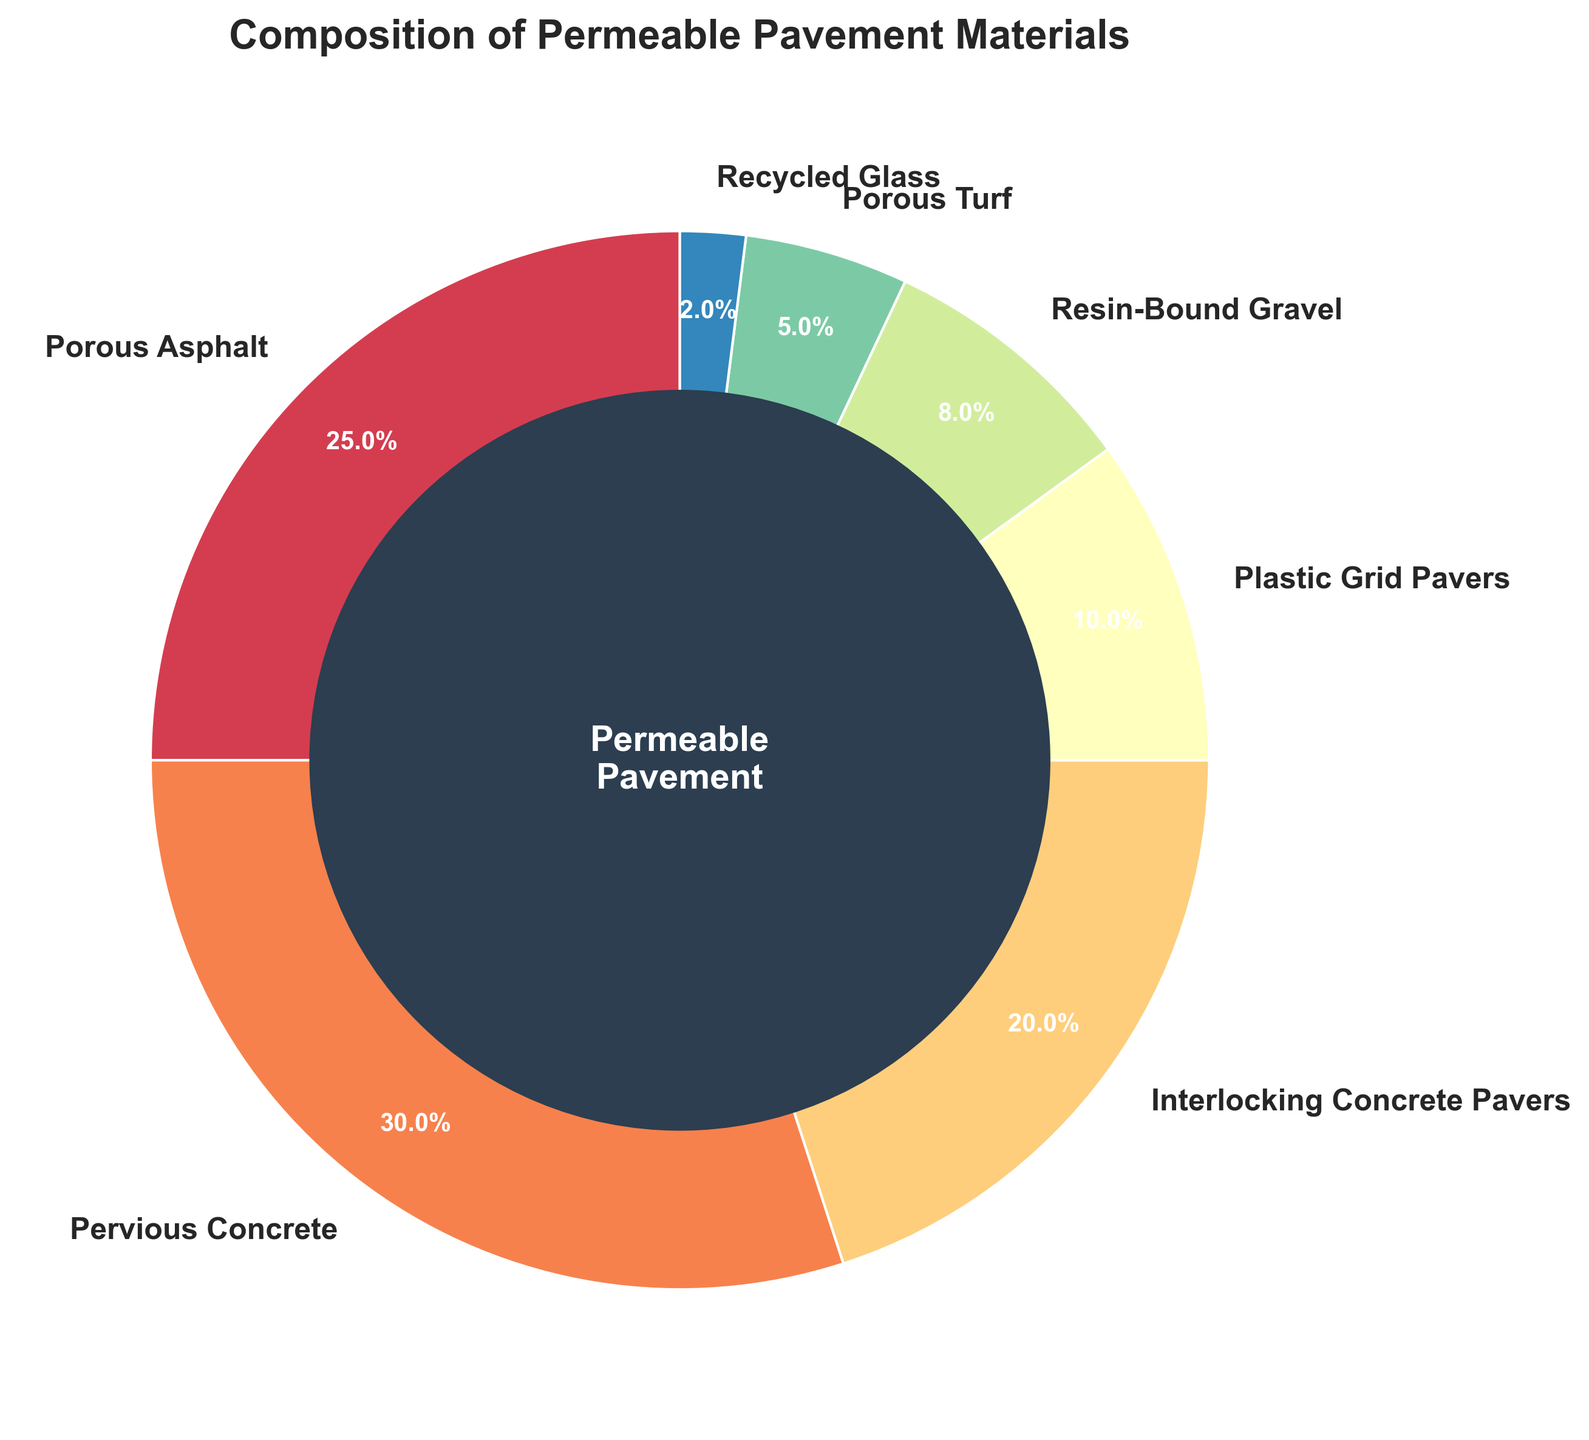What's the total percentage of materials that are not concrete-based? First, identify the materials that are not concrete-based: Porous Asphalt, Plastic Grid Pavers, Resin-Bound Gravel, Porous Turf, and Recycled Glass. Next, sum their percentages: 25% (Porous Asphalt) + 10% (Plastic Grid Pavers) + 8% (Resin-Bound Gravel) + 5% (Porous Turf) + 2% (Recycled Glass) = 50%
Answer: 50% Which material has the second highest percentage? By observing the percentages, Pervious Concrete has the highest at 30%, and Porous Asphalt follows it with 25%, making it the second highest.
Answer: Porous Asphalt If Porous Asphalt and Interlocking Concrete Pavers are combined, what percentage of the total is represented? Add the percentages of Porous Asphalt and Interlocking Concrete Pavers: 25% + 20% = 45%
Answer: 45% What is the difference in percentage between Porous Asphalt and Recycled Glass? Subtract the percentage of Recycled Glass from Porous Asphalt: 25% - 2% = 23%
Answer: 23% How many times more is the percentage of Pervious Concrete compared to Recycled Glass? Divide the percentage of Pervious Concrete by the percentage of Recycled Glass: 30% / 2% = 15 times
Answer: 15 times Which material is represented by the smallest percentage? By observation, Recycled Glass has the smallest percentage at 2%
Answer: Recycled Glass What is the combined percentage of materials that are under 10%? Sum the percentages of Plastic Grid Pavers, Resin-Bound Gravel, Porous Turf, and Recycled Glass: 10% + 8% + 5% + 2% = 25%
Answer: 25% Compare the percentage of Pervious Concrete to Interlocking Concrete Pavers. Which one is larger and by how much? Pervious Concrete is larger. Subtract the percentage of Interlocking Concrete Pavers from Pervious Concrete: 30% - 20% = 10%
Answer: Pervious Concrete, 10% What's the visual attribute that highlights the center of the pie chart? The center of the pie chart is highlighted with a dark blue circular area and contains the text "Permeable Pavement"
Answer: Dark blue circle with text What percentage do Porous Asphalt and Pervious Concrete together represent out of the total? Add the percentages of Porous Asphalt and Pervious Concrete: 25% + 30% = 55%
Answer: 55% 